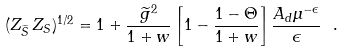<formula> <loc_0><loc_0><loc_500><loc_500>( Z _ { \widetilde { S } } \, Z _ { S } ) ^ { 1 / 2 } = 1 + \frac { \widetilde { g } ^ { 2 } } { 1 + w } \left [ 1 - \frac { 1 - \Theta } { 1 + w } \right ] \frac { A _ { d } \mu ^ { - \epsilon } } { \epsilon } \ .</formula> 